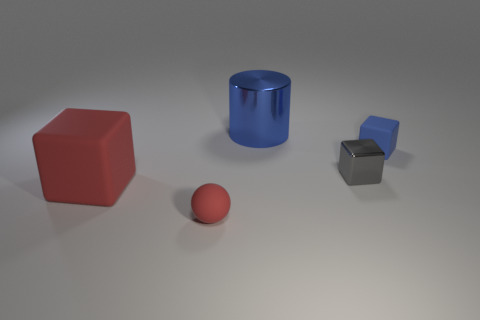Add 4 small red rubber objects. How many objects exist? 9 Subtract all cylinders. How many objects are left? 4 Add 4 red matte blocks. How many red matte blocks are left? 5 Add 4 large cyan rubber spheres. How many large cyan rubber spheres exist? 4 Subtract 0 yellow cubes. How many objects are left? 5 Subtract all large gray metal things. Subtract all matte spheres. How many objects are left? 4 